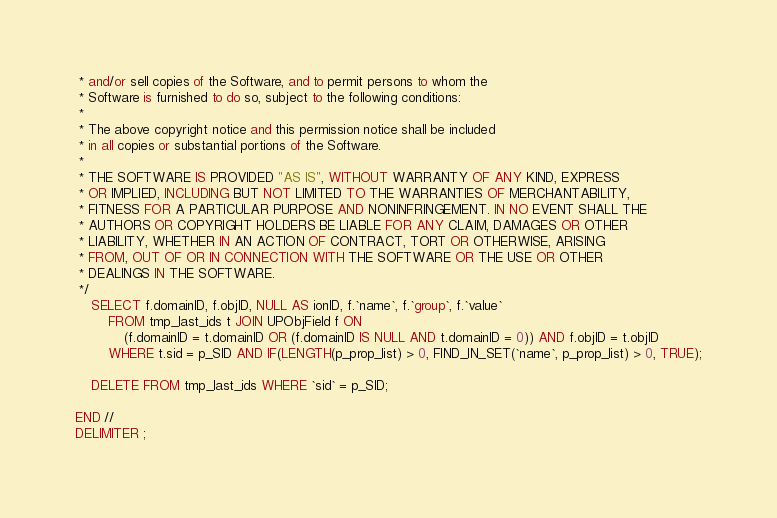<code> <loc_0><loc_0><loc_500><loc_500><_SQL_> * and/or sell copies of the Software, and to permit persons to whom the
 * Software is furnished to do so, subject to the following conditions:
 * 
 * The above copyright notice and this permission notice shall be included
 * in all copies or substantial portions of the Software.
 * 
 * THE SOFTWARE IS PROVIDED "AS IS", WITHOUT WARRANTY OF ANY KIND, EXPRESS
 * OR IMPLIED, INCLUDING BUT NOT LIMITED TO THE WARRANTIES OF MERCHANTABILITY,
 * FITNESS FOR A PARTICULAR PURPOSE AND NONINFRINGEMENT. IN NO EVENT SHALL THE
 * AUTHORS OR COPYRIGHT HOLDERS BE LIABLE FOR ANY CLAIM, DAMAGES OR OTHER
 * LIABILITY, WHETHER IN AN ACTION OF CONTRACT, TORT OR OTHERWISE, ARISING
 * FROM, OUT OF OR IN CONNECTION WITH THE SOFTWARE OR THE USE OR OTHER
 * DEALINGS IN THE SOFTWARE.
 */
    SELECT f.domainID, f.objID, NULL AS ionID, f.`name`, f.`group`, f.`value`
        FROM tmp_last_ids t JOIN UPObjField f ON
            (f.domainID = t.domainID OR (f.domainID IS NULL AND t.domainID = 0)) AND f.objID = t.objID
        WHERE t.sid = p_SID AND IF(LENGTH(p_prop_list) > 0, FIND_IN_SET(`name`, p_prop_list) > 0, TRUE);

    DELETE FROM tmp_last_ids WHERE `sid` = p_SID;

END //
DELIMITER ;
</code> 